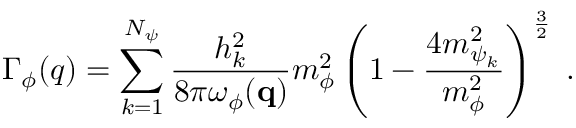<formula> <loc_0><loc_0><loc_500><loc_500>\Gamma _ { \phi } ( q ) = \sum _ { k = 1 } ^ { N _ { \psi } } \frac { h _ { k } ^ { 2 } } { 8 \pi \omega _ { \phi } ( { q } ) } m _ { \phi } ^ { 2 } \left ( 1 - \frac { 4 m _ { \psi _ { k } } ^ { 2 } } { m _ { \phi } ^ { 2 } } \right ) ^ { \frac { 3 } { 2 } } \, .</formula> 